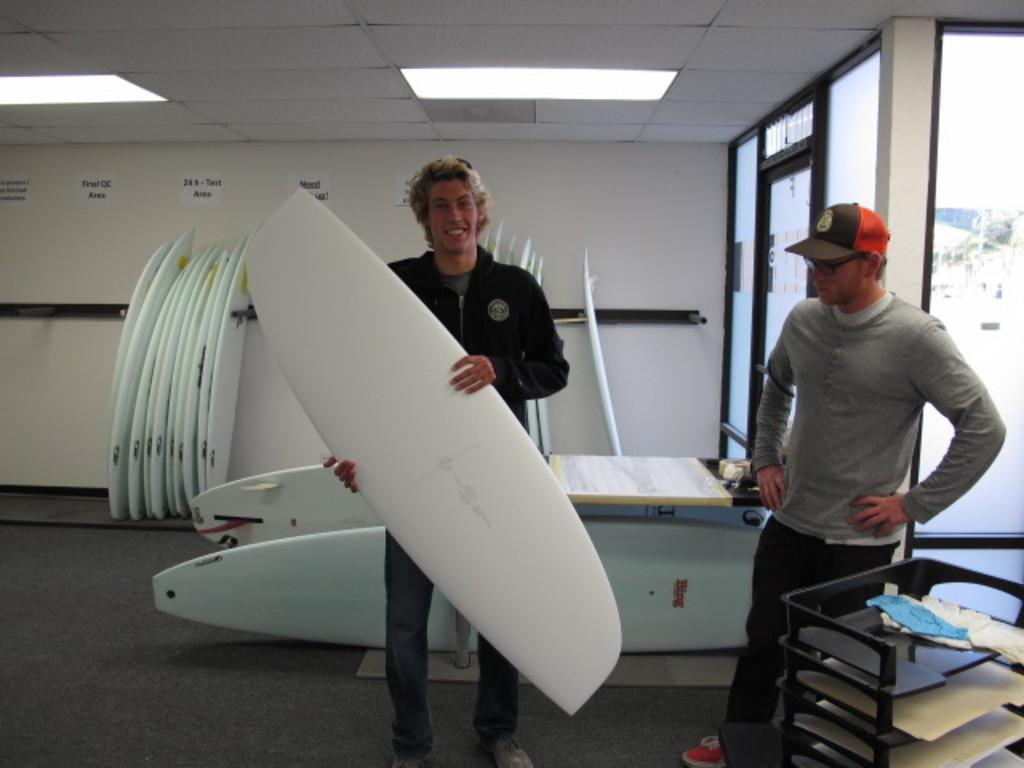How many people are in the image? There are two men standing in the image. What is one of the men holding? One of the men is holding a surfing board. What is the expression on the man holding the surfing board? The man holding the surfing board is smiling. What can be seen in the background of the image? There are multiple boards sliding on the wall in the background of the image. What type of account is the man holding the surfing board discussing with the other man? There is no indication in the image that the men are discussing any accounts. --- Facts: 1. There is a person sitting on a chair in the image. 2. The person is holding a book. 3. There is a table next to the chair. 4. There is a lamp on the table. Absurd Topics: elephant, piano Conversation: What is the person in the image doing? There is a person sitting on a chair in the image. What is the person holding? The person is holding a book. What is next to the chair? There is a table next to the chair. What is on the table? There is a lamp on the table. Reasoning: Let's think step by step in order to produce the conversation. We start by identifying the main subject of the image, which is the person sitting on a chair. Next, we describe what the person is holding, which is a book. Then, we observe what is next to the chair, which is a table. Finally, we describe what is on the table, which is a lamp. Absurd Question/Answer: Can you hear the elephant playing the piano in the image? There is no elephant, piano, or any musical instrument present in the image. 